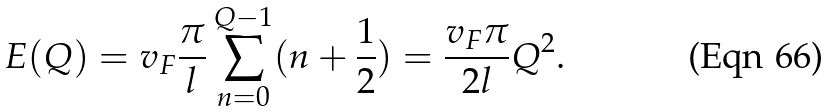<formula> <loc_0><loc_0><loc_500><loc_500>E ( Q ) = v _ { F } \frac { \pi } { l } \sum ^ { Q - 1 } _ { n = 0 } ( n + \frac { 1 } { 2 } ) = \frac { v _ { F } \pi } { 2 l } Q ^ { 2 } .</formula> 